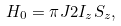<formula> <loc_0><loc_0><loc_500><loc_500>H _ { 0 } = \pi J 2 I _ { z } S _ { z } ,</formula> 